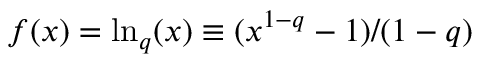Convert formula to latex. <formula><loc_0><loc_0><loc_500><loc_500>f ( x ) = \ln _ { q } ( x ) \equiv ( x ^ { 1 - q } - 1 ) / ( 1 - q )</formula> 